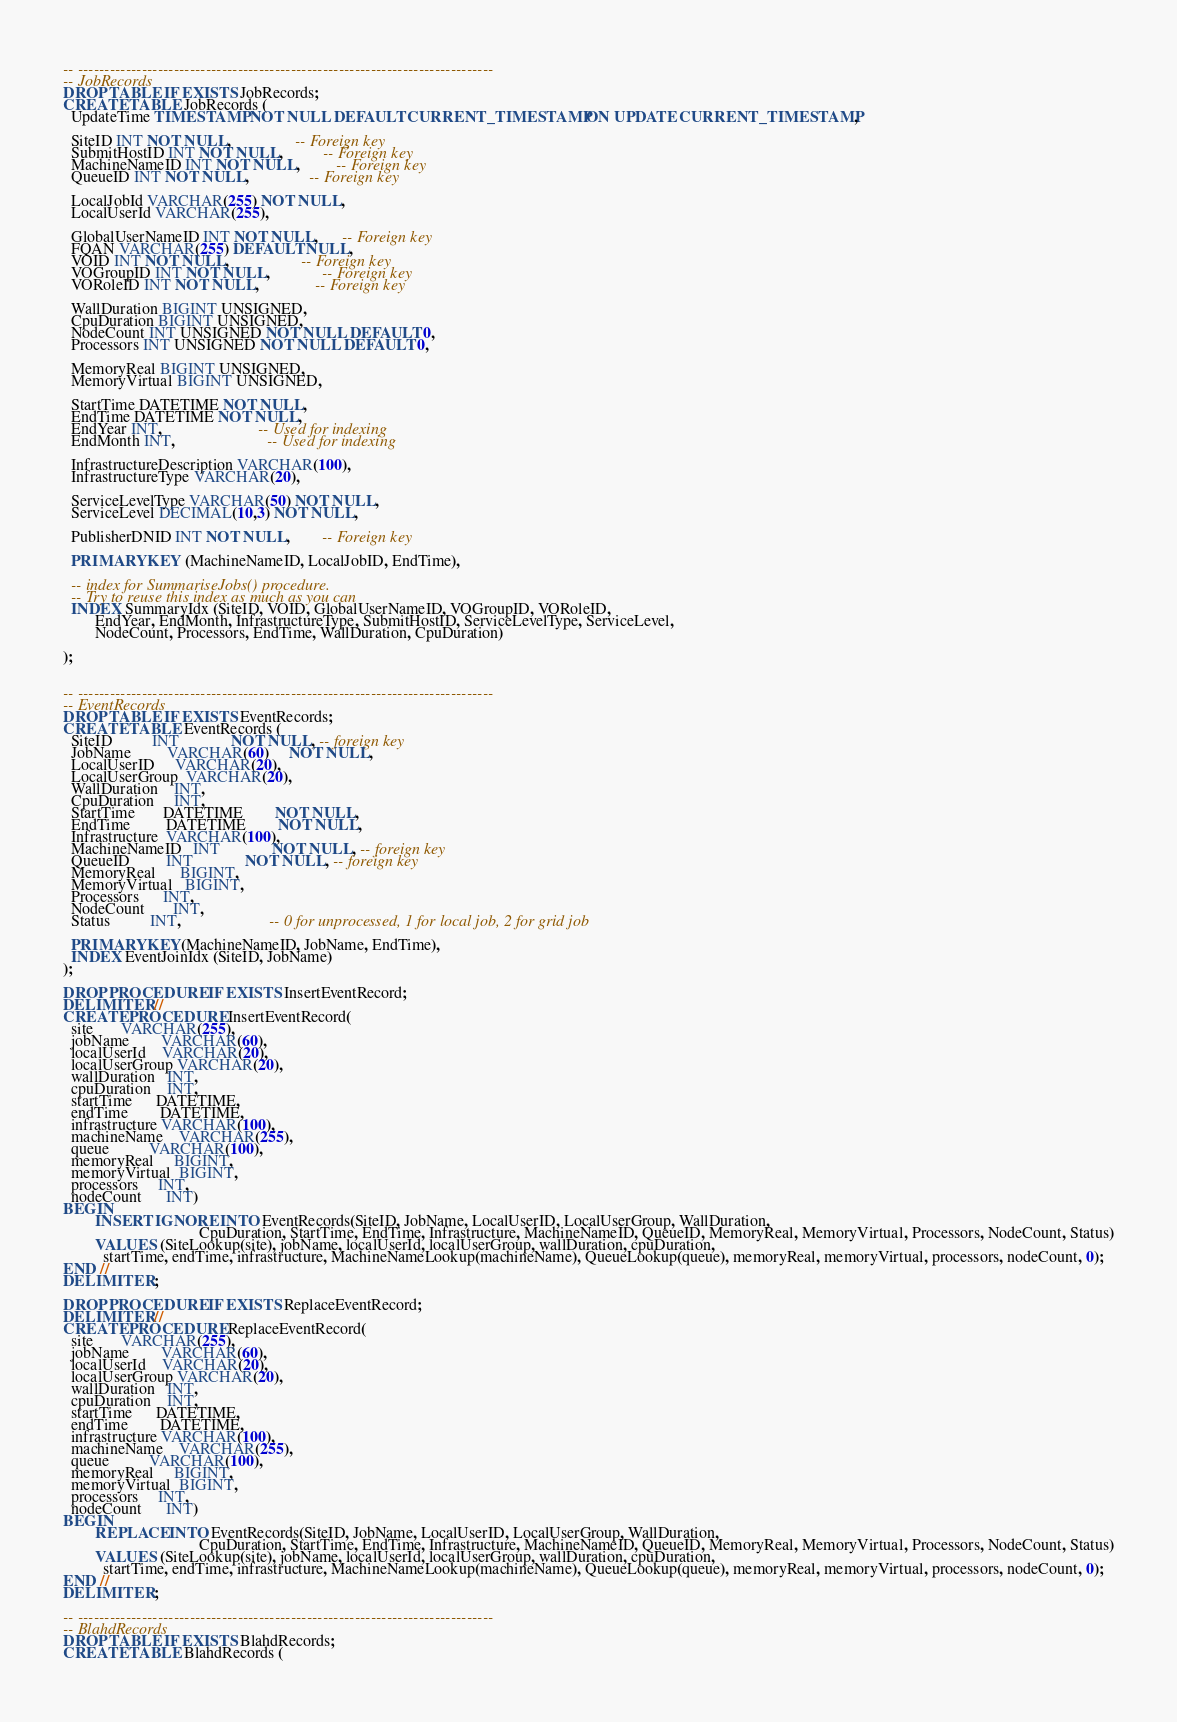Convert code to text. <code><loc_0><loc_0><loc_500><loc_500><_SQL_>
-- ------------------------------------------------------------------------------
-- JobRecords
DROP TABLE IF EXISTS JobRecords;
CREATE TABLE JobRecords (
  UpdateTime TIMESTAMP NOT NULL DEFAULT CURRENT_TIMESTAMP ON UPDATE CURRENT_TIMESTAMP,

  SiteID INT NOT NULL,                -- Foreign key
  SubmitHostID INT NOT NULL,          -- Foreign key
  MachineNameID INT NOT NULL,         -- Foreign key
  QueueID INT NOT NULL,               -- Foreign key

  LocalJobId VARCHAR(255) NOT NULL,
  LocalUserId VARCHAR(255),

  GlobalUserNameID INT NOT NULL,      -- Foreign key
  FQAN VARCHAR(255) DEFAULT NULL,
  VOID INT NOT NULL,                  -- Foreign key
  VOGroupID INT NOT NULL,             -- Foreign key
  VORoleID INT NOT NULL,              -- Foreign key

  WallDuration BIGINT UNSIGNED,
  CpuDuration BIGINT UNSIGNED,
  NodeCount INT UNSIGNED NOT NULL DEFAULT 0,
  Processors INT UNSIGNED NOT NULL DEFAULT 0,

  MemoryReal BIGINT UNSIGNED,
  MemoryVirtual BIGINT UNSIGNED,

  StartTime DATETIME NOT NULL,
  EndTime DATETIME NOT NULL,
  EndYear INT,                        -- Used for indexing
  EndMonth INT,                       -- Used for indexing

  InfrastructureDescription VARCHAR(100),
  InfrastructureType VARCHAR(20),

  ServiceLevelType VARCHAR(50) NOT NULL,
  ServiceLevel DECIMAL(10,3) NOT NULL,

  PublisherDNID INT NOT NULL,        -- Foreign key

  PRIMARY KEY (MachineNameID, LocalJobID, EndTime),

  -- index for SummariseJobs() procedure.
  -- Try to reuse this index as much as you can
  INDEX SummaryIdx (SiteID, VOID, GlobalUserNameID, VOGroupID, VORoleID,
        EndYear, EndMonth, InfrastructureType, SubmitHostID, ServiceLevelType, ServiceLevel,
        NodeCount, Processors, EndTime, WallDuration, CpuDuration)

);


-- ------------------------------------------------------------------------------
-- EventRecords
DROP TABLE IF EXISTS EventRecords;
CREATE TABLE EventRecords (
  SiteID          INT             NOT NULL, -- foreign key
  JobName         VARCHAR(60)     NOT NULL,
  LocalUserID     VARCHAR(20),
  LocalUserGroup  VARCHAR(20),
  WallDuration    INT,
  CpuDuration     INT,
  StartTime       DATETIME        NOT NULL,
  EndTime         DATETIME        NOT NULL,
  Infrastructure  VARCHAR(100),
  MachineNameID   INT             NOT NULL, -- foreign key
  QueueID         INT             NOT NULL, -- foreign key
  MemoryReal      BIGINT,
  MemoryVirtual   BIGINT,
  Processors      INT,
  NodeCount       INT,
  Status          INT,                      -- 0 for unprocessed, 1 for local job, 2 for grid job

  PRIMARY KEY(MachineNameID, JobName, EndTime),
  INDEX EventJoinIdx (SiteID, JobName)
);

DROP PROCEDURE IF EXISTS InsertEventRecord;
DELIMITER //
CREATE PROCEDURE InsertEventRecord(
  site       VARCHAR(255),
  jobName        VARCHAR(60),
  localUserId    VARCHAR(20),
  localUserGroup VARCHAR(20),
  wallDuration   INT,
  cpuDuration    INT,
  startTime      DATETIME,
  endTime        DATETIME,
  infrastructure VARCHAR(100),
  machineName    VARCHAR(255),
  queue          VARCHAR(100),
  memoryReal     BIGINT,
  memoryVirtual  BIGINT,
  processors     INT,
  nodeCount      INT)
BEGIN
        INSERT IGNORE INTO EventRecords(SiteID, JobName, LocalUserID, LocalUserGroup, WallDuration,
                                  CpuDuration, StartTime, EndTime, Infrastructure, MachineNameID, QueueID, MemoryReal, MemoryVirtual, Processors, NodeCount, Status)
        VALUES (SiteLookup(site), jobName, localUserId, localUserGroup, wallDuration, cpuDuration,
          startTime, endTime, infrastructure, MachineNameLookup(machineName), QueueLookup(queue), memoryReal, memoryVirtual, processors, nodeCount, 0);
END //
DELIMITER ;

DROP PROCEDURE IF EXISTS ReplaceEventRecord;
DELIMITER //
CREATE PROCEDURE ReplaceEventRecord(
  site       VARCHAR(255),
  jobName        VARCHAR(60),
  localUserId    VARCHAR(20),
  localUserGroup VARCHAR(20),
  wallDuration   INT,
  cpuDuration    INT,
  startTime      DATETIME,
  endTime        DATETIME,
  infrastructure VARCHAR(100),
  machineName    VARCHAR(255),
  queue          VARCHAR(100),
  memoryReal     BIGINT,
  memoryVirtual  BIGINT,
  processors     INT,
  nodeCount      INT)
BEGIN
        REPLACE INTO EventRecords(SiteID, JobName, LocalUserID, LocalUserGroup, WallDuration,
                                  CpuDuration, StartTime, EndTime, Infrastructure, MachineNameID, QueueID, MemoryReal, MemoryVirtual, Processors, NodeCount, Status)
        VALUES (SiteLookup(site), jobName, localUserId, localUserGroup, wallDuration, cpuDuration,
          startTime, endTime, infrastructure, MachineNameLookup(machineName), QueueLookup(queue), memoryReal, memoryVirtual, processors, nodeCount, 0);
END //
DELIMITER ;

-- ------------------------------------------------------------------------------
-- BlahdRecords
DROP TABLE IF EXISTS BlahdRecords;
CREATE TABLE BlahdRecords (</code> 